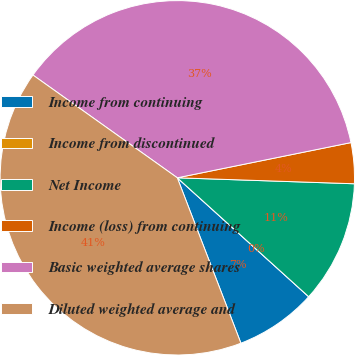<chart> <loc_0><loc_0><loc_500><loc_500><pie_chart><fcel>Income from continuing<fcel>Income from discontinued<fcel>Net Income<fcel>Income (loss) from continuing<fcel>Basic weighted average shares<fcel>Diluted weighted average and<nl><fcel>7.45%<fcel>0.0%<fcel>11.17%<fcel>3.72%<fcel>36.97%<fcel>40.69%<nl></chart> 